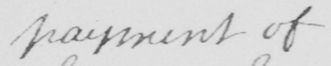What does this handwritten line say? payment of 